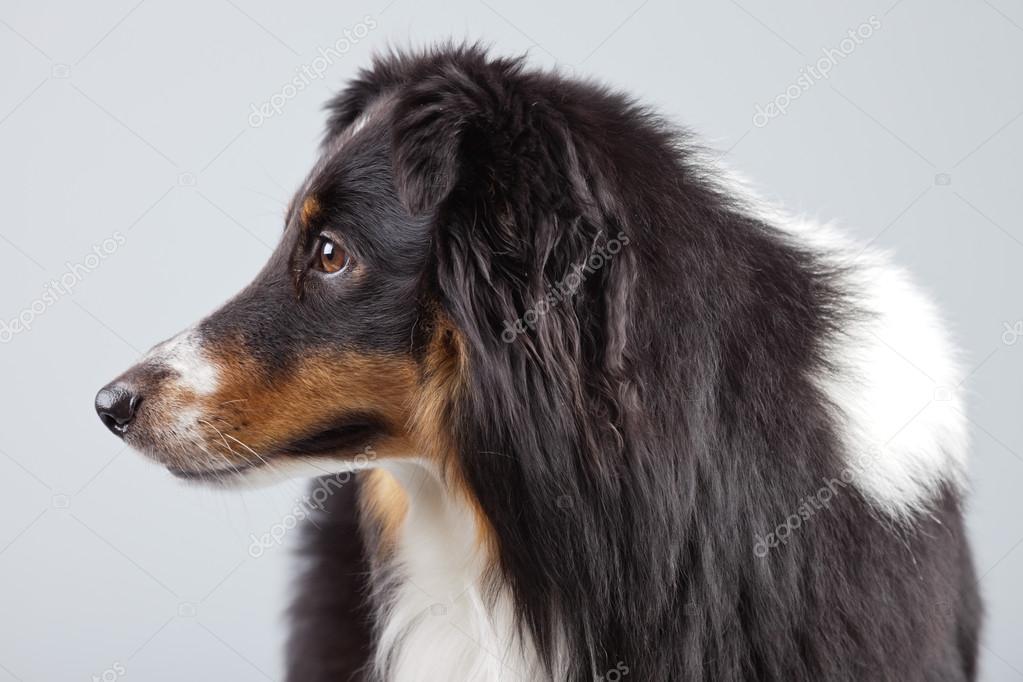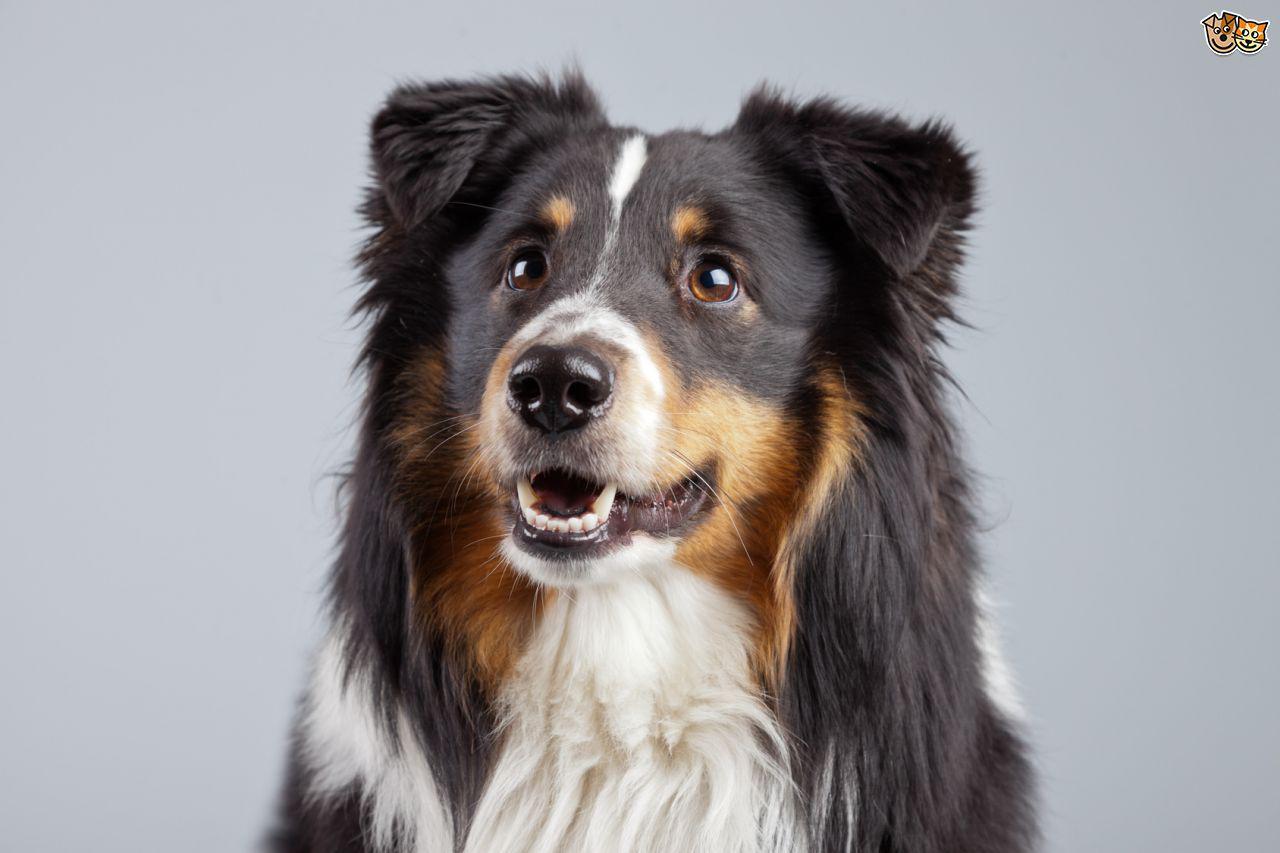The first image is the image on the left, the second image is the image on the right. Assess this claim about the two images: "The left image depicts only a canine-type animal on the grass.". Correct or not? Answer yes or no. No. 